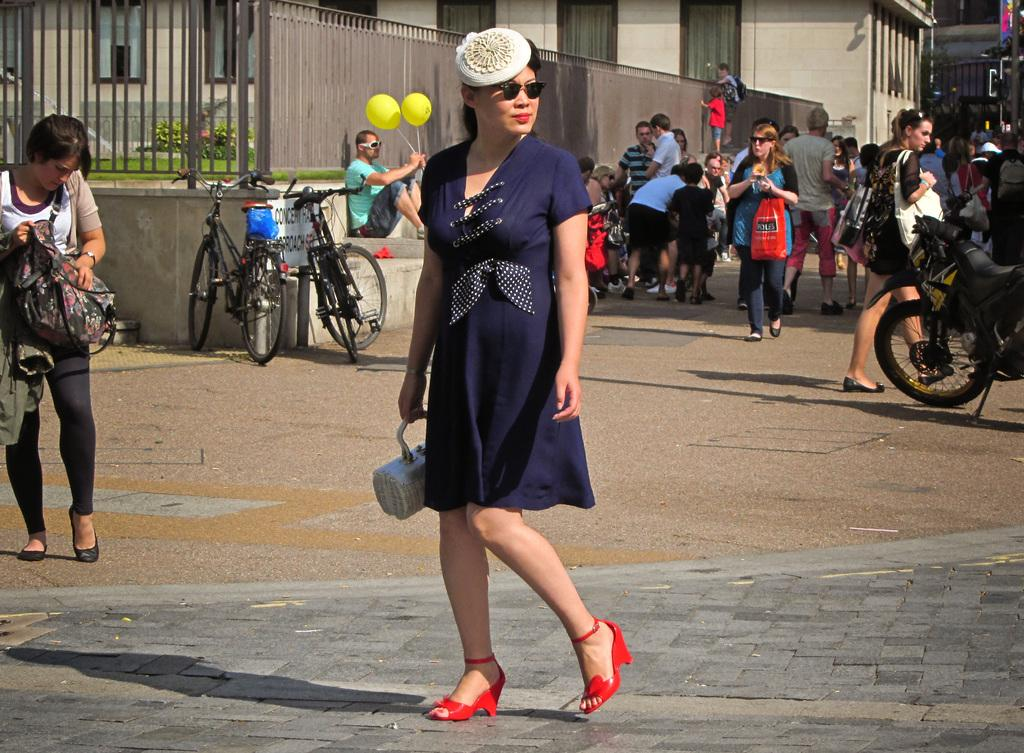Who is the main subject in the foreground of the image? There is a woman in the foreground of the image. Can you describe the people behind the woman? There are other people behind the woman. What type of objects can be seen in the image? Vehicles are visible in the image. What can be seen in the background of the image? There is a building in the background of the image. What type of glue is the woman using to fix the toy in the image? There is no glue or toy present in the image. 